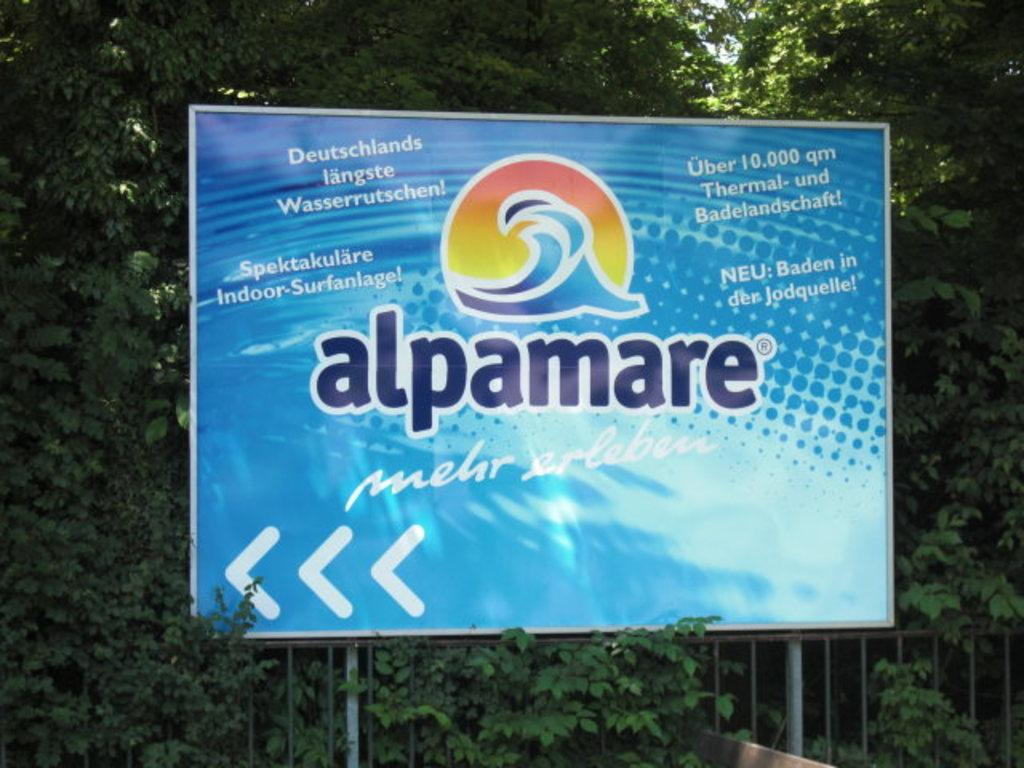What is the main feature of the image? There is a huge banner in the image. What color is the banner? The banner is blue in color. What other objects can be seen in the image? There is metal railing and green trees in the image. What can be seen in the background of the image? The sky is visible in the background of the image. Where is the plastic toad hiding in the image? There is no plastic toad present in the image. What type of cellar can be seen in the image? There is no cellar present in the image. 